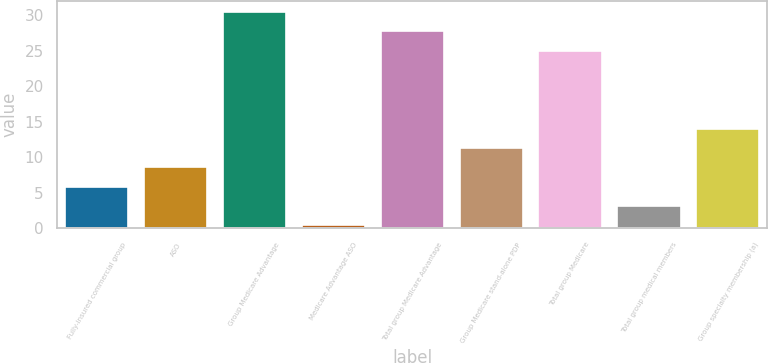Convert chart to OTSL. <chart><loc_0><loc_0><loc_500><loc_500><bar_chart><fcel>Fully-insured commercial group<fcel>ASO<fcel>Group Medicare Advantage<fcel>Medicare Advantage ASO<fcel>Total group Medicare Advantage<fcel>Group Medicare stand-alone PDP<fcel>Total group Medicare<fcel>Total group medical members<fcel>Group specialty membership (a)<nl><fcel>5.84<fcel>8.56<fcel>30.44<fcel>0.4<fcel>27.72<fcel>11.28<fcel>25<fcel>3.12<fcel>14<nl></chart> 